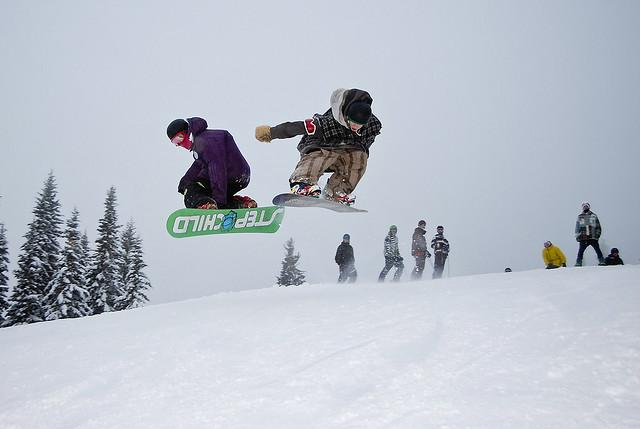Which famous person fits the description on the bottom of the board?

Choices:
A) liberace
B) amy smart
C) jessica biel
D) zoe kravitz zoe kravitz 